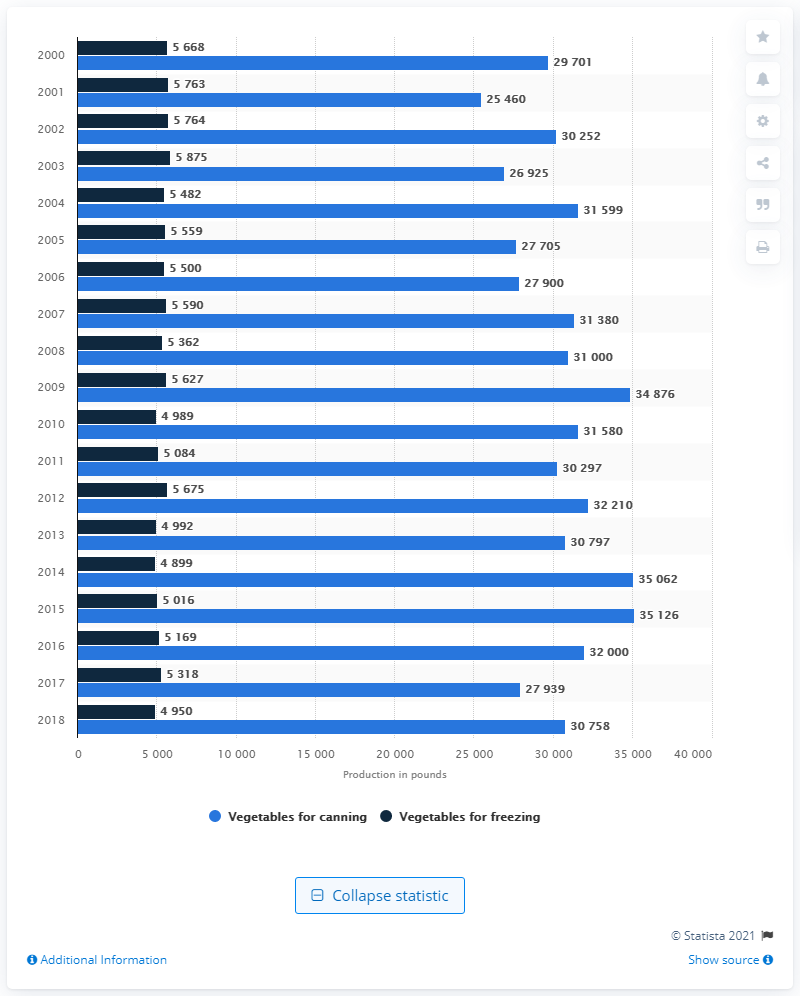Highlight a few significant elements in this photo. In the United States, a total of 32,210 pounds of vegetables were processed for canning in 2016. 